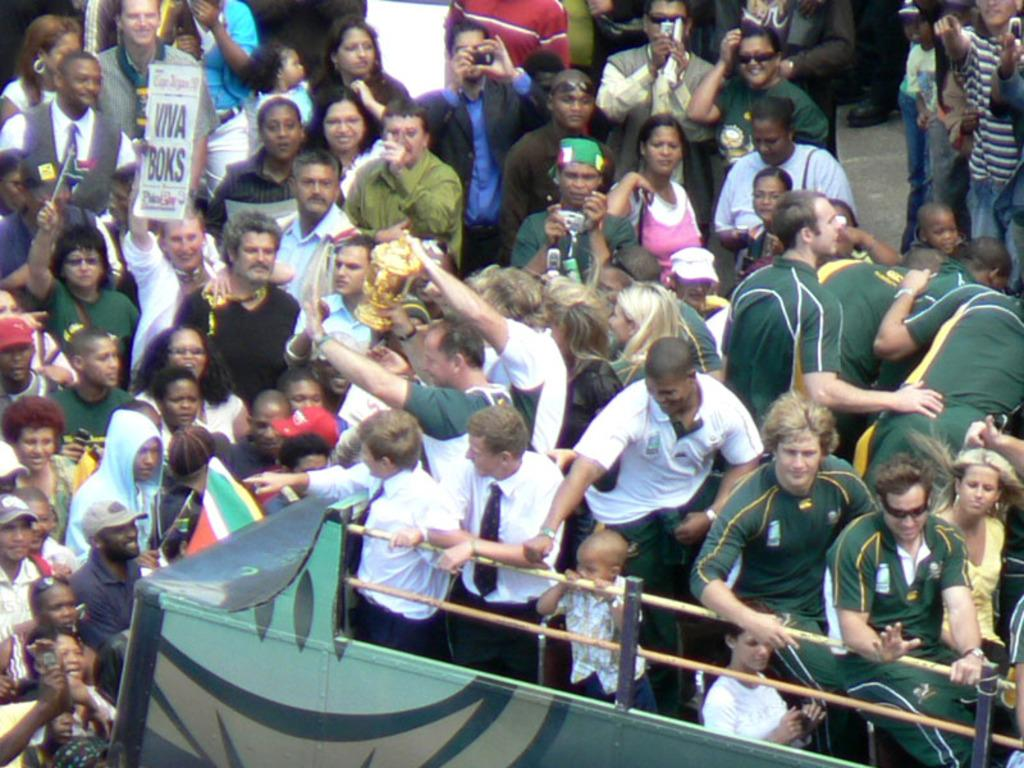What is happening in the image involving the groups of persons? The persons in the image are standing and holding an object. Can you describe the object that the persons are holding? Unfortunately, the specific object cannot be determined from the provided facts. What else can be seen in the image besides the groups of persons? There is a stick attached to a stand in the image. How many holes can be seen in the image? There is no mention of any holes in the image, so it cannot be determined from the provided facts. What type of society is depicted in the image? The provided facts do not give any information about the society or social context of the image. 